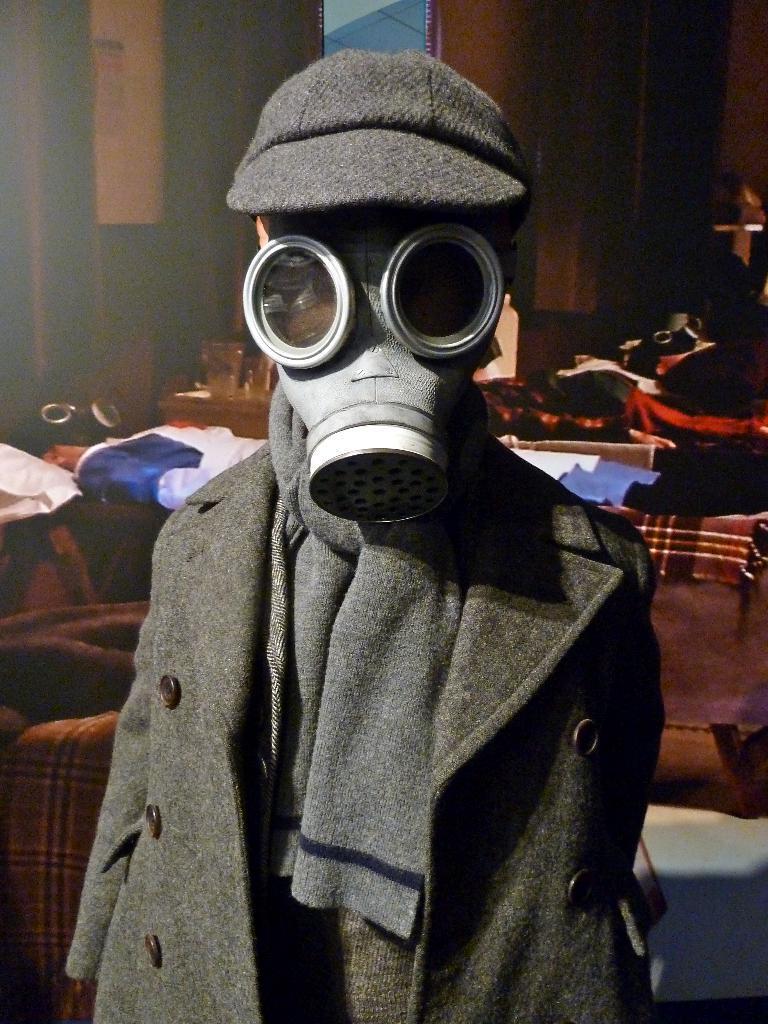In one or two sentences, can you explain what this image depicts? In the image we can see a child standing, wearing clothes, cap and a face mask. There are clothes and objects. 